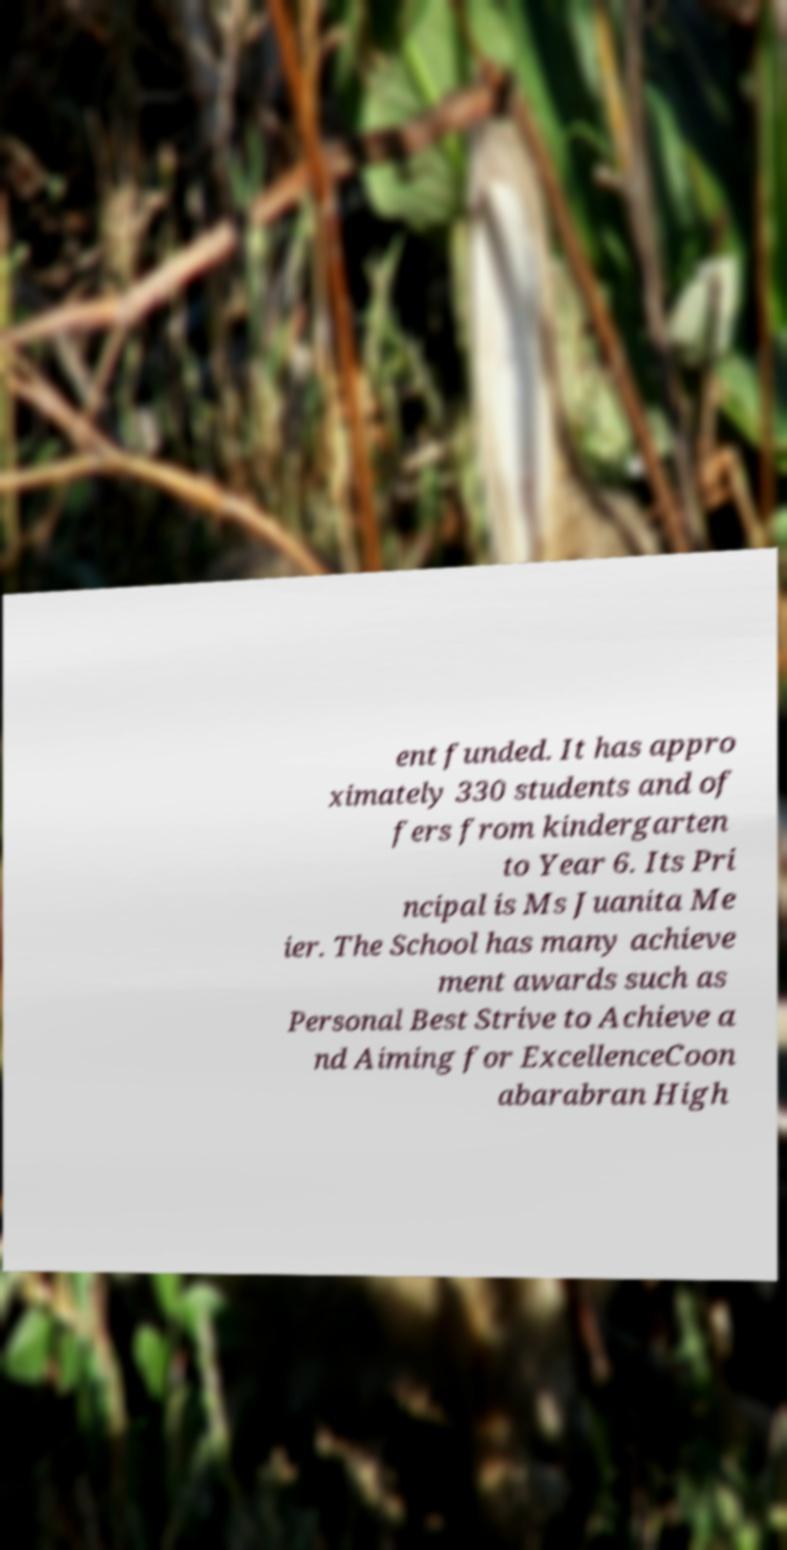Please read and relay the text visible in this image. What does it say? ent funded. It has appro ximately 330 students and of fers from kindergarten to Year 6. Its Pri ncipal is Ms Juanita Me ier. The School has many achieve ment awards such as Personal Best Strive to Achieve a nd Aiming for ExcellenceCoon abarabran High 